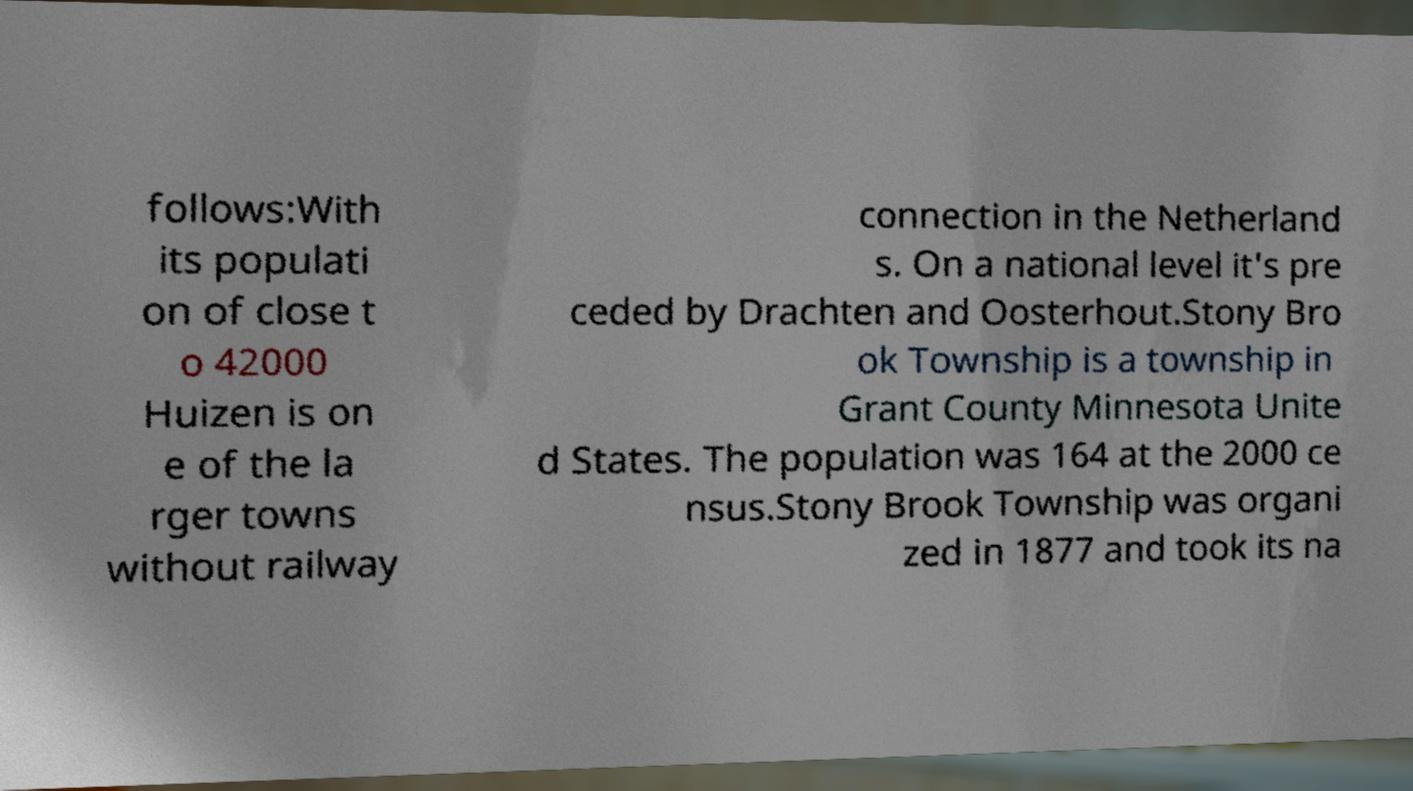Could you extract and type out the text from this image? follows:With its populati on of close t o 42000 Huizen is on e of the la rger towns without railway connection in the Netherland s. On a national level it's pre ceded by Drachten and Oosterhout.Stony Bro ok Township is a township in Grant County Minnesota Unite d States. The population was 164 at the 2000 ce nsus.Stony Brook Township was organi zed in 1877 and took its na 